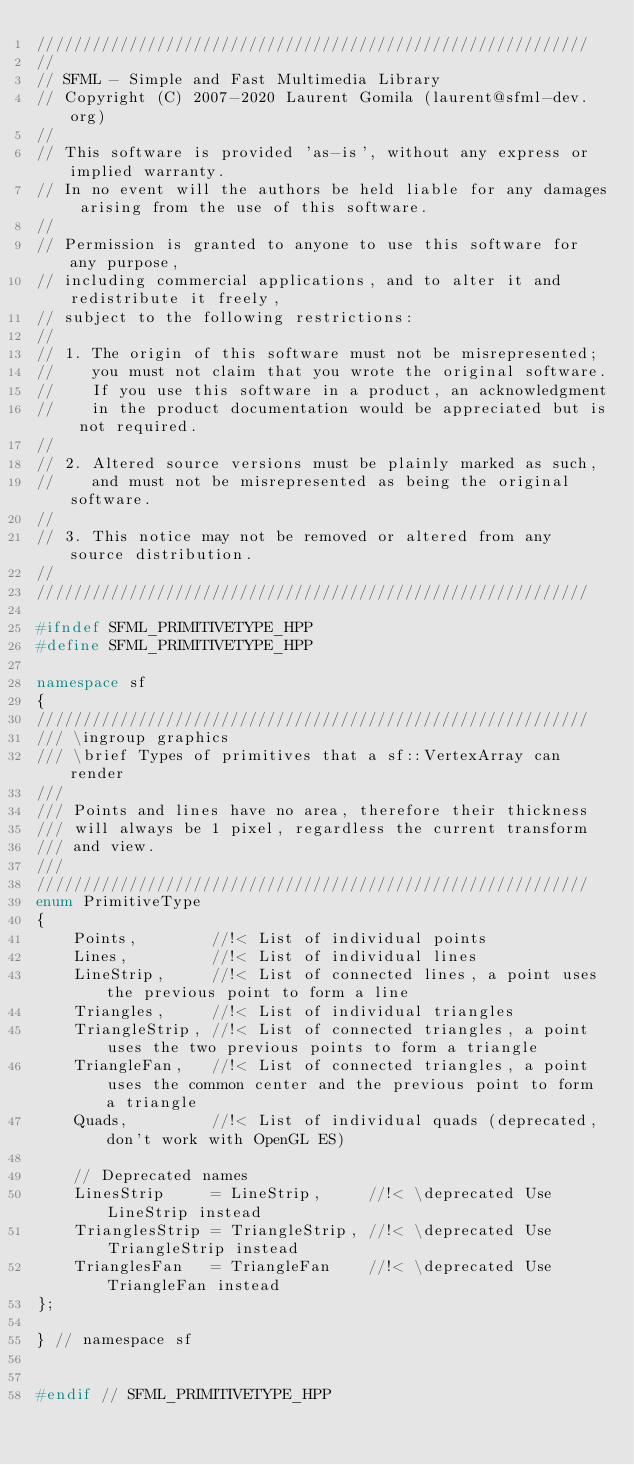<code> <loc_0><loc_0><loc_500><loc_500><_C++_>////////////////////////////////////////////////////////////
//
// SFML - Simple and Fast Multimedia Library
// Copyright (C) 2007-2020 Laurent Gomila (laurent@sfml-dev.org)
//
// This software is provided 'as-is', without any express or implied warranty.
// In no event will the authors be held liable for any damages arising from the use of this software.
//
// Permission is granted to anyone to use this software for any purpose,
// including commercial applications, and to alter it and redistribute it freely,
// subject to the following restrictions:
//
// 1. The origin of this software must not be misrepresented;
//    you must not claim that you wrote the original software.
//    If you use this software in a product, an acknowledgment
//    in the product documentation would be appreciated but is not required.
//
// 2. Altered source versions must be plainly marked as such,
//    and must not be misrepresented as being the original software.
//
// 3. This notice may not be removed or altered from any source distribution.
//
////////////////////////////////////////////////////////////

#ifndef SFML_PRIMITIVETYPE_HPP
#define SFML_PRIMITIVETYPE_HPP

namespace sf
{
////////////////////////////////////////////////////////////
/// \ingroup graphics
/// \brief Types of primitives that a sf::VertexArray can render
///
/// Points and lines have no area, therefore their thickness
/// will always be 1 pixel, regardless the current transform
/// and view.
///
////////////////////////////////////////////////////////////
enum PrimitiveType
{
    Points,        //!< List of individual points
    Lines,         //!< List of individual lines
    LineStrip,     //!< List of connected lines, a point uses the previous point to form a line
    Triangles,     //!< List of individual triangles
    TriangleStrip, //!< List of connected triangles, a point uses the two previous points to form a triangle
    TriangleFan,   //!< List of connected triangles, a point uses the common center and the previous point to form a triangle
    Quads,         //!< List of individual quads (deprecated, don't work with OpenGL ES)

    // Deprecated names
    LinesStrip     = LineStrip,     //!< \deprecated Use LineStrip instead
    TrianglesStrip = TriangleStrip, //!< \deprecated Use TriangleStrip instead
    TrianglesFan   = TriangleFan    //!< \deprecated Use TriangleFan instead
};

} // namespace sf


#endif // SFML_PRIMITIVETYPE_HPP
</code> 